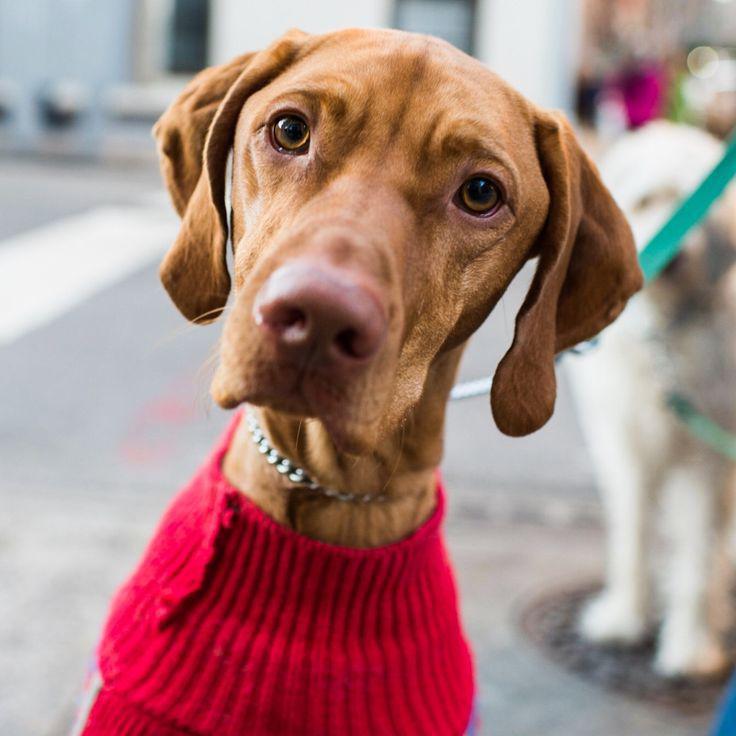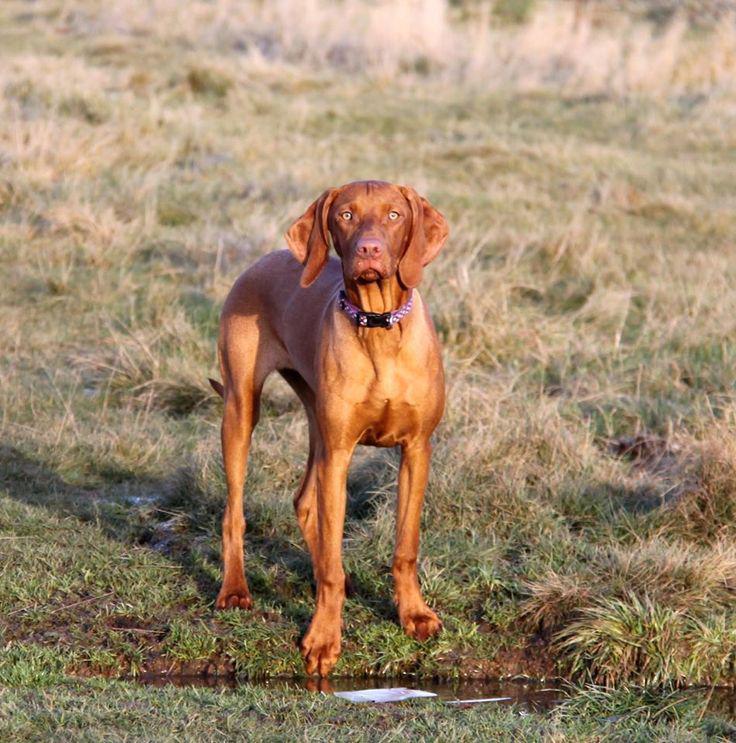The first image is the image on the left, the second image is the image on the right. For the images shown, is this caption "The left image shows a row of three dogs with upright heads, and the right image shows one upright dog wearing a collar." true? Answer yes or no. No. The first image is the image on the left, the second image is the image on the right. Considering the images on both sides, is "In the image on the left there are 3 dogs." valid? Answer yes or no. No. 